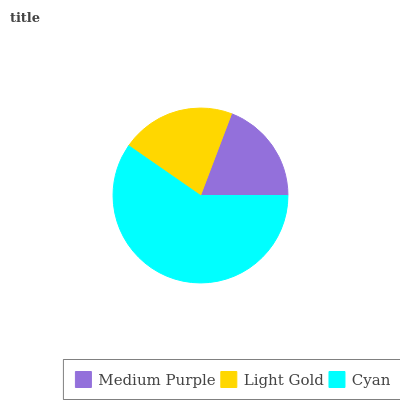Is Medium Purple the minimum?
Answer yes or no. Yes. Is Cyan the maximum?
Answer yes or no. Yes. Is Light Gold the minimum?
Answer yes or no. No. Is Light Gold the maximum?
Answer yes or no. No. Is Light Gold greater than Medium Purple?
Answer yes or no. Yes. Is Medium Purple less than Light Gold?
Answer yes or no. Yes. Is Medium Purple greater than Light Gold?
Answer yes or no. No. Is Light Gold less than Medium Purple?
Answer yes or no. No. Is Light Gold the high median?
Answer yes or no. Yes. Is Light Gold the low median?
Answer yes or no. Yes. Is Cyan the high median?
Answer yes or no. No. Is Medium Purple the low median?
Answer yes or no. No. 